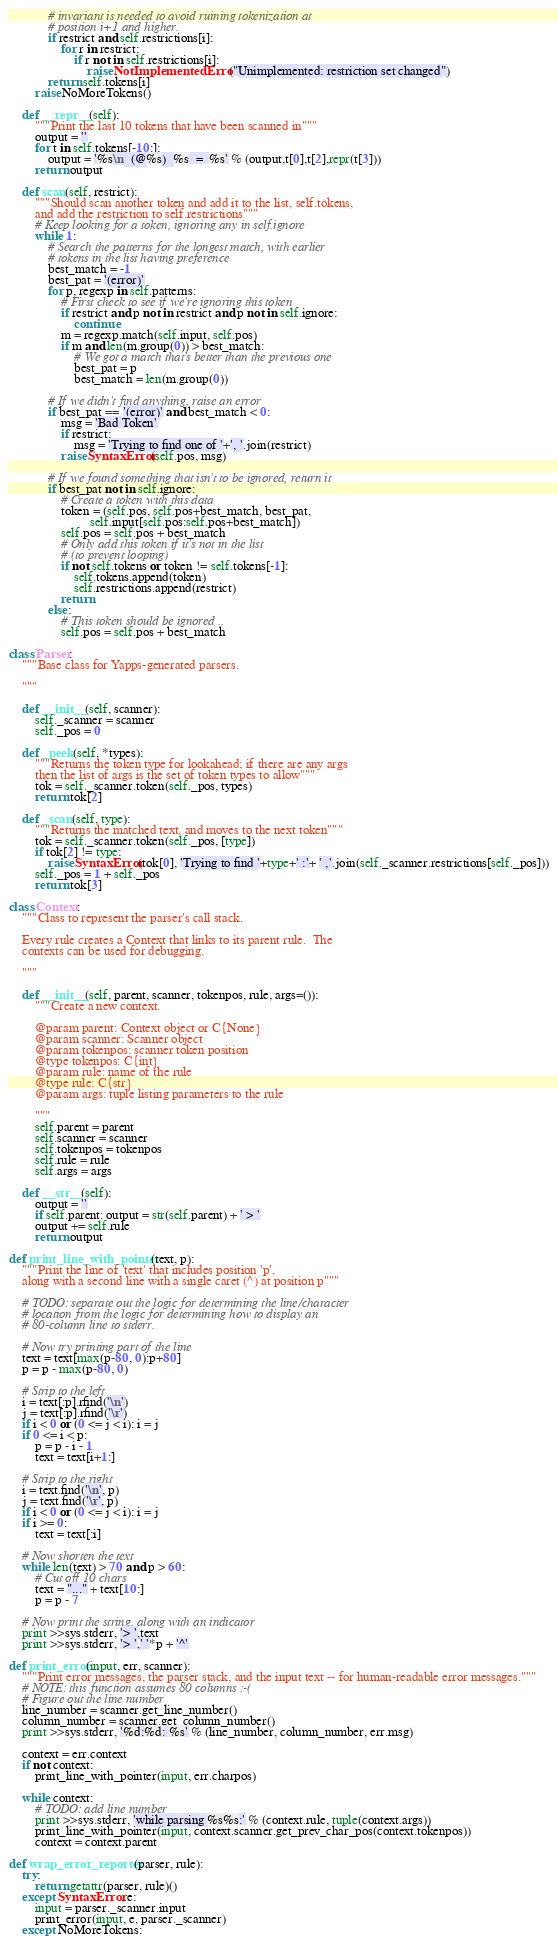Convert code to text. <code><loc_0><loc_0><loc_500><loc_500><_Python_>            # invariant is needed to avoid ruining tokenization at
            # position i+1 and higher.
            if restrict and self.restrictions[i]:
                for r in restrict:
                    if r not in self.restrictions[i]:
                        raise NotImplementedError("Unimplemented: restriction set changed")
            return self.tokens[i]
        raise NoMoreTokens()

    def __repr__(self):
        """Print the last 10 tokens that have been scanned in"""
        output = ''
        for t in self.tokens[-10:]:
            output = '%s\n  (@%s)  %s  =  %s' % (output,t[0],t[2],repr(t[3]))
        return output

    def scan(self, restrict):
        """Should scan another token and add it to the list, self.tokens,
        and add the restriction to self.restrictions"""
        # Keep looking for a token, ignoring any in self.ignore
        while 1:
            # Search the patterns for the longest match, with earlier
            # tokens in the list having preference
            best_match = -1
            best_pat = '(error)'
            for p, regexp in self.patterns:
                # First check to see if we're ignoring this token
                if restrict and p not in restrict and p not in self.ignore:
                    continue
                m = regexp.match(self.input, self.pos)
                if m and len(m.group(0)) > best_match:
                    # We got a match that's better than the previous one
                    best_pat = p
                    best_match = len(m.group(0))

            # If we didn't find anything, raise an error
            if best_pat == '(error)' and best_match < 0:
                msg = 'Bad Token'
                if restrict:
                    msg = 'Trying to find one of '+', '.join(restrict)
                raise SyntaxError(self.pos, msg)

            # If we found something that isn't to be ignored, return it
            if best_pat not in self.ignore:
                # Create a token with this data
                token = (self.pos, self.pos+best_match, best_pat,
                         self.input[self.pos:self.pos+best_match])
                self.pos = self.pos + best_match
                # Only add this token if it's not in the list
                # (to prevent looping)
                if not self.tokens or token != self.tokens[-1]:
                    self.tokens.append(token)
                    self.restrictions.append(restrict)
                return
            else:
                # This token should be ignored ..
                self.pos = self.pos + best_match

class Parser:
    """Base class for Yapps-generated parsers.

    """

    def __init__(self, scanner):
        self._scanner = scanner
        self._pos = 0

    def _peek(self, *types):
        """Returns the token type for lookahead; if there are any args
        then the list of args is the set of token types to allow"""
        tok = self._scanner.token(self._pos, types)
        return tok[2]

    def _scan(self, type):
        """Returns the matched text, and moves to the next token"""
        tok = self._scanner.token(self._pos, [type])
        if tok[2] != type:
            raise SyntaxError(tok[0], 'Trying to find '+type+' :'+ ' ,'.join(self._scanner.restrictions[self._pos]))
        self._pos = 1 + self._pos
        return tok[3]

class Context:
    """Class to represent the parser's call stack.

    Every rule creates a Context that links to its parent rule.  The
    contexts can be used for debugging.

    """

    def __init__(self, parent, scanner, tokenpos, rule, args=()):
        """Create a new context.

        @param parent: Context object or C{None}
        @param scanner: Scanner object
        @param tokenpos: scanner token position
        @type tokenpos: C{int}
        @param rule: name of the rule
        @type rule: C{str}
        @param args: tuple listing parameters to the rule

        """
        self.parent = parent
        self.scanner = scanner
        self.tokenpos = tokenpos
        self.rule = rule
        self.args = args

    def __str__(self):
        output = ''
        if self.parent: output = str(self.parent) + ' > '
        output += self.rule
        return output

def print_line_with_pointer(text, p):
    """Print the line of 'text' that includes position 'p',
    along with a second line with a single caret (^) at position p"""

    # TODO: separate out the logic for determining the line/character
    # location from the logic for determining how to display an
    # 80-column line to stderr.

    # Now try printing part of the line
    text = text[max(p-80, 0):p+80]
    p = p - max(p-80, 0)

    # Strip to the left
    i = text[:p].rfind('\n')
    j = text[:p].rfind('\r')
    if i < 0 or (0 <= j < i): i = j
    if 0 <= i < p:
        p = p - i - 1
        text = text[i+1:]

    # Strip to the right
    i = text.find('\n', p)
    j = text.find('\r', p)
    if i < 0 or (0 <= j < i): i = j
    if i >= 0:
        text = text[:i]

    # Now shorten the text
    while len(text) > 70 and p > 60:
        # Cut off 10 chars
        text = "..." + text[10:]
        p = p - 7

    # Now print the string, along with an indicator
    print >>sys.stderr, '> ',text
    print >>sys.stderr, '> ',' '*p + '^'

def print_error(input, err, scanner):
    """Print error messages, the parser stack, and the input text -- for human-readable error messages."""
    # NOTE: this function assumes 80 columns :-(
    # Figure out the line number
    line_number = scanner.get_line_number()
    column_number = scanner.get_column_number()
    print >>sys.stderr, '%d:%d: %s' % (line_number, column_number, err.msg)

    context = err.context
    if not context:
        print_line_with_pointer(input, err.charpos)

    while context:
        # TODO: add line number
        print >>sys.stderr, 'while parsing %s%s:' % (context.rule, tuple(context.args))
        print_line_with_pointer(input, context.scanner.get_prev_char_pos(context.tokenpos))
        context = context.parent

def wrap_error_reporter(parser, rule):
    try:
        return getattr(parser, rule)()
    except SyntaxError, e:
        input = parser._scanner.input
        print_error(input, e, parser._scanner)
    except NoMoreTokens:</code> 